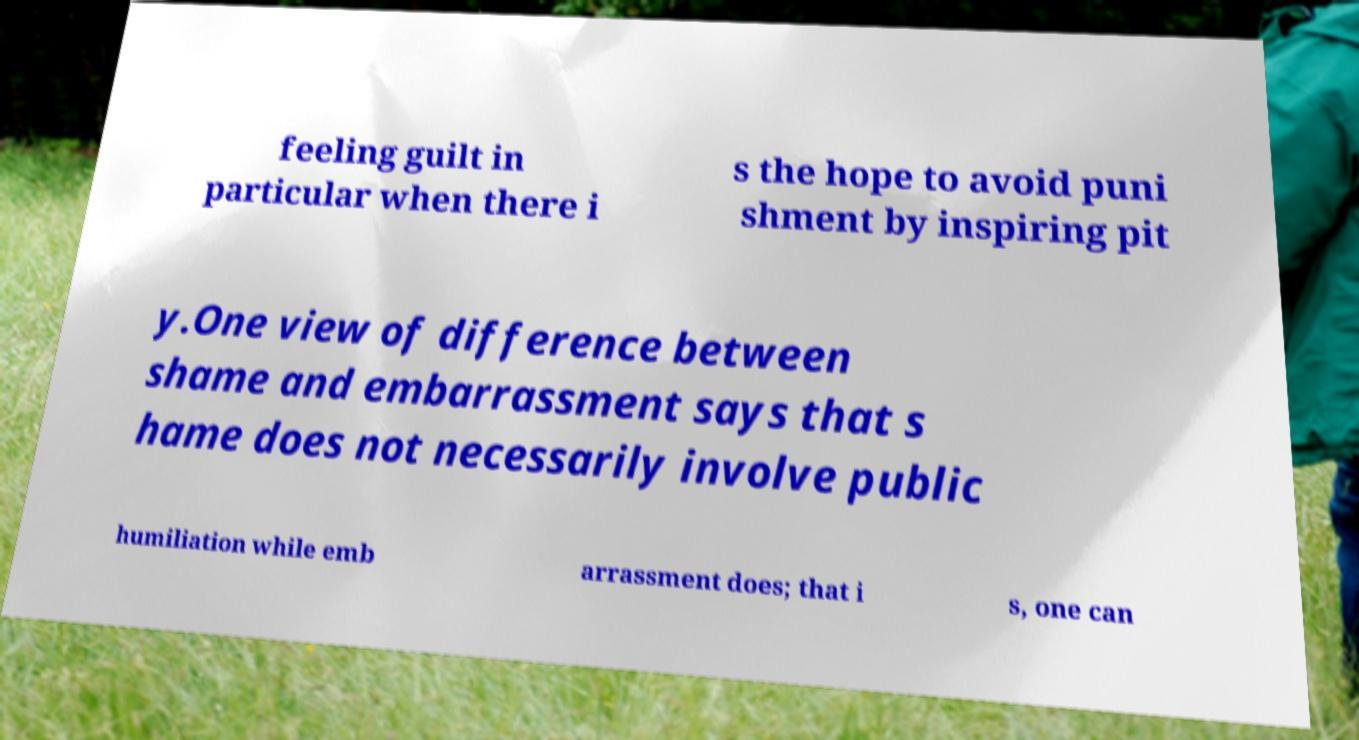I need the written content from this picture converted into text. Can you do that? feeling guilt in particular when there i s the hope to avoid puni shment by inspiring pit y.One view of difference between shame and embarrassment says that s hame does not necessarily involve public humiliation while emb arrassment does; that i s, one can 